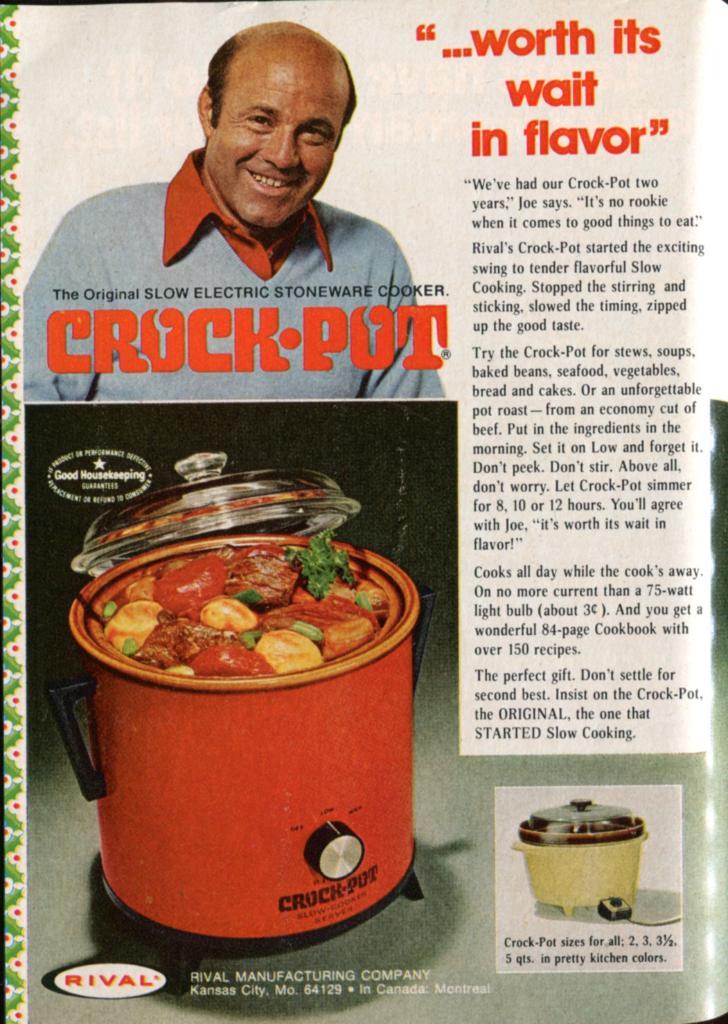What does the quote say in red on the top right?
Provide a succinct answer. Worth its wait in flavor. 